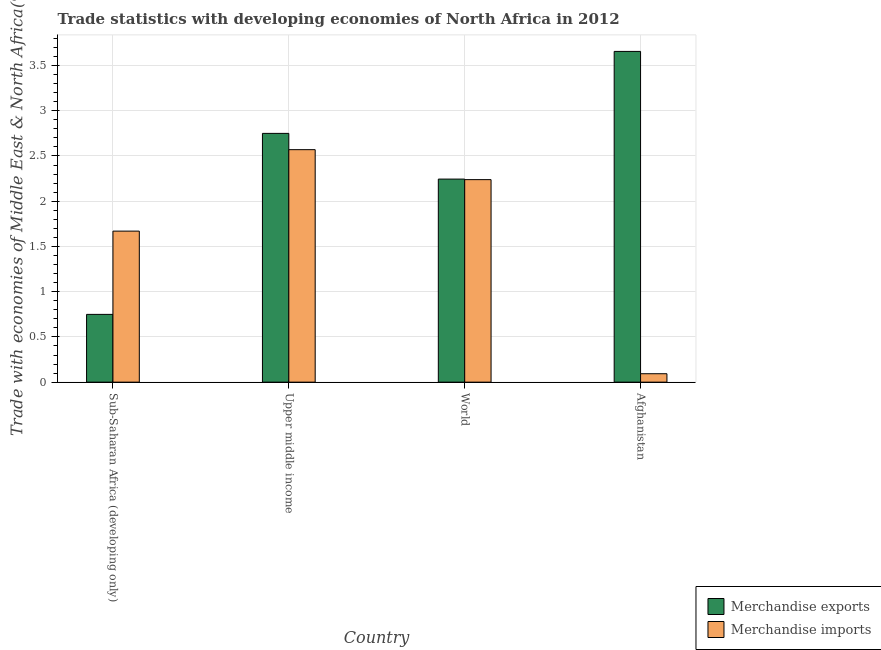How many different coloured bars are there?
Provide a succinct answer. 2. How many groups of bars are there?
Your answer should be compact. 4. Are the number of bars per tick equal to the number of legend labels?
Provide a succinct answer. Yes. How many bars are there on the 3rd tick from the left?
Ensure brevity in your answer.  2. What is the label of the 4th group of bars from the left?
Your response must be concise. Afghanistan. In how many cases, is the number of bars for a given country not equal to the number of legend labels?
Ensure brevity in your answer.  0. What is the merchandise imports in Afghanistan?
Provide a succinct answer. 0.09. Across all countries, what is the maximum merchandise imports?
Your answer should be compact. 2.57. Across all countries, what is the minimum merchandise imports?
Ensure brevity in your answer.  0.09. In which country was the merchandise exports maximum?
Keep it short and to the point. Afghanistan. In which country was the merchandise exports minimum?
Offer a terse response. Sub-Saharan Africa (developing only). What is the total merchandise imports in the graph?
Offer a very short reply. 6.57. What is the difference between the merchandise exports in Sub-Saharan Africa (developing only) and that in Upper middle income?
Keep it short and to the point. -2. What is the difference between the merchandise exports in Sub-Saharan Africa (developing only) and the merchandise imports in Upper middle income?
Ensure brevity in your answer.  -1.82. What is the average merchandise imports per country?
Your response must be concise. 1.64. What is the difference between the merchandise exports and merchandise imports in Sub-Saharan Africa (developing only)?
Offer a very short reply. -0.92. What is the ratio of the merchandise exports in Afghanistan to that in World?
Offer a very short reply. 1.63. Is the merchandise exports in Afghanistan less than that in Upper middle income?
Ensure brevity in your answer.  No. What is the difference between the highest and the second highest merchandise imports?
Your answer should be very brief. 0.33. What is the difference between the highest and the lowest merchandise exports?
Offer a terse response. 2.91. In how many countries, is the merchandise imports greater than the average merchandise imports taken over all countries?
Offer a very short reply. 3. What does the 2nd bar from the right in Upper middle income represents?
Provide a succinct answer. Merchandise exports. How many bars are there?
Offer a very short reply. 8. How many countries are there in the graph?
Make the answer very short. 4. What is the difference between two consecutive major ticks on the Y-axis?
Make the answer very short. 0.5. Does the graph contain any zero values?
Your response must be concise. No. Where does the legend appear in the graph?
Your answer should be compact. Bottom right. How are the legend labels stacked?
Make the answer very short. Vertical. What is the title of the graph?
Your answer should be compact. Trade statistics with developing economies of North Africa in 2012. Does "Measles" appear as one of the legend labels in the graph?
Make the answer very short. No. What is the label or title of the Y-axis?
Ensure brevity in your answer.  Trade with economies of Middle East & North Africa(%). What is the Trade with economies of Middle East & North Africa(%) of Merchandise exports in Sub-Saharan Africa (developing only)?
Keep it short and to the point. 0.75. What is the Trade with economies of Middle East & North Africa(%) in Merchandise imports in Sub-Saharan Africa (developing only)?
Ensure brevity in your answer.  1.67. What is the Trade with economies of Middle East & North Africa(%) in Merchandise exports in Upper middle income?
Provide a short and direct response. 2.75. What is the Trade with economies of Middle East & North Africa(%) of Merchandise imports in Upper middle income?
Ensure brevity in your answer.  2.57. What is the Trade with economies of Middle East & North Africa(%) in Merchandise exports in World?
Offer a very short reply. 2.24. What is the Trade with economies of Middle East & North Africa(%) in Merchandise imports in World?
Provide a short and direct response. 2.24. What is the Trade with economies of Middle East & North Africa(%) of Merchandise exports in Afghanistan?
Offer a very short reply. 3.66. What is the Trade with economies of Middle East & North Africa(%) of Merchandise imports in Afghanistan?
Your answer should be compact. 0.09. Across all countries, what is the maximum Trade with economies of Middle East & North Africa(%) of Merchandise exports?
Your answer should be very brief. 3.66. Across all countries, what is the maximum Trade with economies of Middle East & North Africa(%) of Merchandise imports?
Your answer should be very brief. 2.57. Across all countries, what is the minimum Trade with economies of Middle East & North Africa(%) of Merchandise exports?
Give a very brief answer. 0.75. Across all countries, what is the minimum Trade with economies of Middle East & North Africa(%) of Merchandise imports?
Your response must be concise. 0.09. What is the total Trade with economies of Middle East & North Africa(%) in Merchandise exports in the graph?
Offer a very short reply. 9.4. What is the total Trade with economies of Middle East & North Africa(%) of Merchandise imports in the graph?
Provide a succinct answer. 6.57. What is the difference between the Trade with economies of Middle East & North Africa(%) of Merchandise exports in Sub-Saharan Africa (developing only) and that in Upper middle income?
Provide a succinct answer. -2. What is the difference between the Trade with economies of Middle East & North Africa(%) of Merchandise imports in Sub-Saharan Africa (developing only) and that in Upper middle income?
Give a very brief answer. -0.9. What is the difference between the Trade with economies of Middle East & North Africa(%) of Merchandise exports in Sub-Saharan Africa (developing only) and that in World?
Ensure brevity in your answer.  -1.5. What is the difference between the Trade with economies of Middle East & North Africa(%) of Merchandise imports in Sub-Saharan Africa (developing only) and that in World?
Offer a terse response. -0.57. What is the difference between the Trade with economies of Middle East & North Africa(%) of Merchandise exports in Sub-Saharan Africa (developing only) and that in Afghanistan?
Make the answer very short. -2.91. What is the difference between the Trade with economies of Middle East & North Africa(%) of Merchandise imports in Sub-Saharan Africa (developing only) and that in Afghanistan?
Give a very brief answer. 1.58. What is the difference between the Trade with economies of Middle East & North Africa(%) of Merchandise exports in Upper middle income and that in World?
Give a very brief answer. 0.51. What is the difference between the Trade with economies of Middle East & North Africa(%) in Merchandise imports in Upper middle income and that in World?
Offer a very short reply. 0.33. What is the difference between the Trade with economies of Middle East & North Africa(%) of Merchandise exports in Upper middle income and that in Afghanistan?
Make the answer very short. -0.91. What is the difference between the Trade with economies of Middle East & North Africa(%) of Merchandise imports in Upper middle income and that in Afghanistan?
Your answer should be compact. 2.48. What is the difference between the Trade with economies of Middle East & North Africa(%) in Merchandise exports in World and that in Afghanistan?
Ensure brevity in your answer.  -1.41. What is the difference between the Trade with economies of Middle East & North Africa(%) in Merchandise imports in World and that in Afghanistan?
Offer a very short reply. 2.15. What is the difference between the Trade with economies of Middle East & North Africa(%) in Merchandise exports in Sub-Saharan Africa (developing only) and the Trade with economies of Middle East & North Africa(%) in Merchandise imports in Upper middle income?
Give a very brief answer. -1.82. What is the difference between the Trade with economies of Middle East & North Africa(%) of Merchandise exports in Sub-Saharan Africa (developing only) and the Trade with economies of Middle East & North Africa(%) of Merchandise imports in World?
Your answer should be very brief. -1.49. What is the difference between the Trade with economies of Middle East & North Africa(%) in Merchandise exports in Sub-Saharan Africa (developing only) and the Trade with economies of Middle East & North Africa(%) in Merchandise imports in Afghanistan?
Give a very brief answer. 0.66. What is the difference between the Trade with economies of Middle East & North Africa(%) in Merchandise exports in Upper middle income and the Trade with economies of Middle East & North Africa(%) in Merchandise imports in World?
Your answer should be very brief. 0.51. What is the difference between the Trade with economies of Middle East & North Africa(%) of Merchandise exports in Upper middle income and the Trade with economies of Middle East & North Africa(%) of Merchandise imports in Afghanistan?
Keep it short and to the point. 2.66. What is the difference between the Trade with economies of Middle East & North Africa(%) in Merchandise exports in World and the Trade with economies of Middle East & North Africa(%) in Merchandise imports in Afghanistan?
Give a very brief answer. 2.15. What is the average Trade with economies of Middle East & North Africa(%) of Merchandise exports per country?
Your answer should be very brief. 2.35. What is the average Trade with economies of Middle East & North Africa(%) of Merchandise imports per country?
Your response must be concise. 1.64. What is the difference between the Trade with economies of Middle East & North Africa(%) of Merchandise exports and Trade with economies of Middle East & North Africa(%) of Merchandise imports in Sub-Saharan Africa (developing only)?
Offer a terse response. -0.92. What is the difference between the Trade with economies of Middle East & North Africa(%) of Merchandise exports and Trade with economies of Middle East & North Africa(%) of Merchandise imports in Upper middle income?
Give a very brief answer. 0.18. What is the difference between the Trade with economies of Middle East & North Africa(%) in Merchandise exports and Trade with economies of Middle East & North Africa(%) in Merchandise imports in World?
Provide a succinct answer. 0.01. What is the difference between the Trade with economies of Middle East & North Africa(%) in Merchandise exports and Trade with economies of Middle East & North Africa(%) in Merchandise imports in Afghanistan?
Ensure brevity in your answer.  3.56. What is the ratio of the Trade with economies of Middle East & North Africa(%) of Merchandise exports in Sub-Saharan Africa (developing only) to that in Upper middle income?
Make the answer very short. 0.27. What is the ratio of the Trade with economies of Middle East & North Africa(%) of Merchandise imports in Sub-Saharan Africa (developing only) to that in Upper middle income?
Offer a terse response. 0.65. What is the ratio of the Trade with economies of Middle East & North Africa(%) in Merchandise exports in Sub-Saharan Africa (developing only) to that in World?
Your answer should be compact. 0.33. What is the ratio of the Trade with economies of Middle East & North Africa(%) in Merchandise imports in Sub-Saharan Africa (developing only) to that in World?
Your response must be concise. 0.75. What is the ratio of the Trade with economies of Middle East & North Africa(%) in Merchandise exports in Sub-Saharan Africa (developing only) to that in Afghanistan?
Give a very brief answer. 0.2. What is the ratio of the Trade with economies of Middle East & North Africa(%) of Merchandise imports in Sub-Saharan Africa (developing only) to that in Afghanistan?
Ensure brevity in your answer.  17.95. What is the ratio of the Trade with economies of Middle East & North Africa(%) of Merchandise exports in Upper middle income to that in World?
Offer a terse response. 1.23. What is the ratio of the Trade with economies of Middle East & North Africa(%) of Merchandise imports in Upper middle income to that in World?
Your answer should be compact. 1.15. What is the ratio of the Trade with economies of Middle East & North Africa(%) of Merchandise exports in Upper middle income to that in Afghanistan?
Provide a short and direct response. 0.75. What is the ratio of the Trade with economies of Middle East & North Africa(%) of Merchandise imports in Upper middle income to that in Afghanistan?
Give a very brief answer. 27.62. What is the ratio of the Trade with economies of Middle East & North Africa(%) in Merchandise exports in World to that in Afghanistan?
Provide a short and direct response. 0.61. What is the ratio of the Trade with economies of Middle East & North Africa(%) in Merchandise imports in World to that in Afghanistan?
Make the answer very short. 24.06. What is the difference between the highest and the second highest Trade with economies of Middle East & North Africa(%) in Merchandise exports?
Offer a very short reply. 0.91. What is the difference between the highest and the second highest Trade with economies of Middle East & North Africa(%) in Merchandise imports?
Provide a short and direct response. 0.33. What is the difference between the highest and the lowest Trade with economies of Middle East & North Africa(%) in Merchandise exports?
Offer a very short reply. 2.91. What is the difference between the highest and the lowest Trade with economies of Middle East & North Africa(%) of Merchandise imports?
Ensure brevity in your answer.  2.48. 